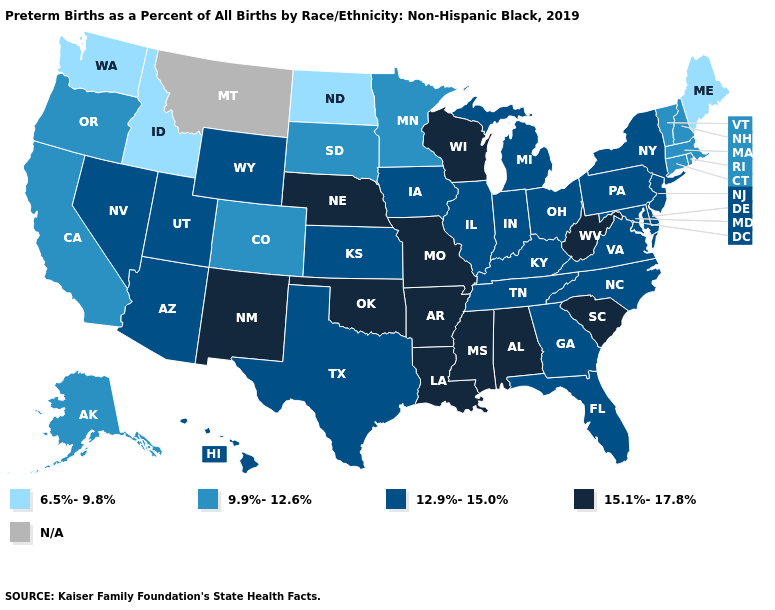Among the states that border Kentucky , does Missouri have the lowest value?
Concise answer only. No. Name the states that have a value in the range 15.1%-17.8%?
Be succinct. Alabama, Arkansas, Louisiana, Mississippi, Missouri, Nebraska, New Mexico, Oklahoma, South Carolina, West Virginia, Wisconsin. Name the states that have a value in the range N/A?
Concise answer only. Montana. Name the states that have a value in the range 12.9%-15.0%?
Give a very brief answer. Arizona, Delaware, Florida, Georgia, Hawaii, Illinois, Indiana, Iowa, Kansas, Kentucky, Maryland, Michigan, Nevada, New Jersey, New York, North Carolina, Ohio, Pennsylvania, Tennessee, Texas, Utah, Virginia, Wyoming. What is the highest value in the South ?
Keep it brief. 15.1%-17.8%. Does North Dakota have the lowest value in the USA?
Quick response, please. Yes. What is the value of Arkansas?
Short answer required. 15.1%-17.8%. Does Kentucky have the highest value in the South?
Short answer required. No. Name the states that have a value in the range 15.1%-17.8%?
Be succinct. Alabama, Arkansas, Louisiana, Mississippi, Missouri, Nebraska, New Mexico, Oklahoma, South Carolina, West Virginia, Wisconsin. Does Rhode Island have the highest value in the Northeast?
Write a very short answer. No. Does New Hampshire have the highest value in the Northeast?
Be succinct. No. Name the states that have a value in the range 12.9%-15.0%?
Concise answer only. Arizona, Delaware, Florida, Georgia, Hawaii, Illinois, Indiana, Iowa, Kansas, Kentucky, Maryland, Michigan, Nevada, New Jersey, New York, North Carolina, Ohio, Pennsylvania, Tennessee, Texas, Utah, Virginia, Wyoming. Does Kentucky have the highest value in the USA?
Write a very short answer. No. What is the value of Arkansas?
Concise answer only. 15.1%-17.8%. Name the states that have a value in the range 12.9%-15.0%?
Give a very brief answer. Arizona, Delaware, Florida, Georgia, Hawaii, Illinois, Indiana, Iowa, Kansas, Kentucky, Maryland, Michigan, Nevada, New Jersey, New York, North Carolina, Ohio, Pennsylvania, Tennessee, Texas, Utah, Virginia, Wyoming. 